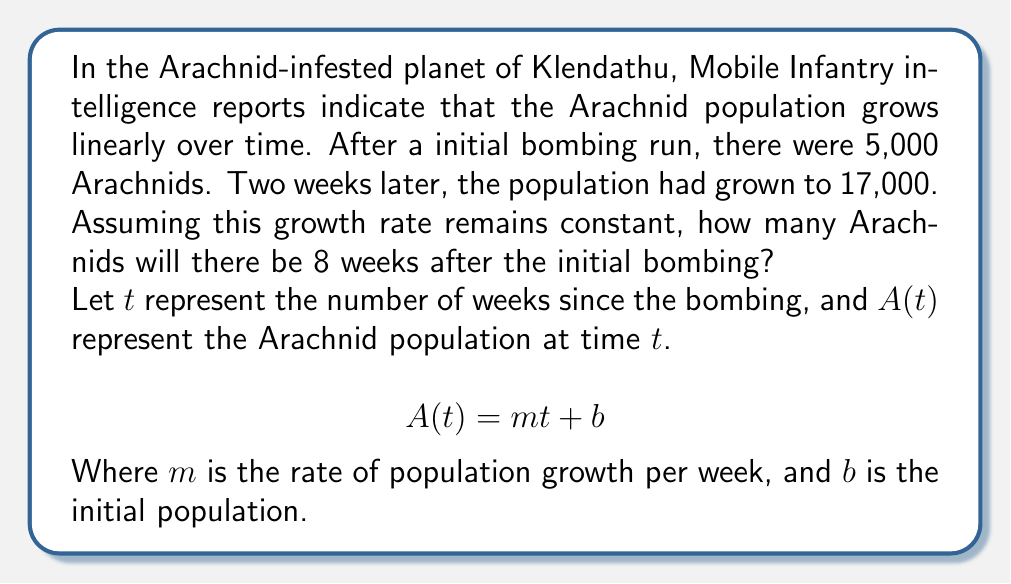Could you help me with this problem? Let's approach this problem step-by-step, like planning a strategic assault in an RTS game:

1) We know the initial population (b) is 5,000:
   $$A(0) = b = 5,000$$

2) We can set up an equation for the population after 2 weeks:
   $$A(2) = m(2) + 5,000 = 17,000$$

3) Now we can solve for the rate of growth (m):
   $$m(2) = 17,000 - 5,000$$
   $$m(2) = 12,000$$
   $$m = 6,000$$

4) So our linear equation for Arachnid population growth is:
   $$A(t) = 6,000t + 5,000$$

5) To find the population after 8 weeks, we substitute t = 8:
   $$A(8) = 6,000(8) + 5,000$$
   $$A(8) = 48,000 + 5,000$$
   $$A(8) = 53,000$$

Just as in Starship Troopers, the Arachnid threat grows rapidly if left unchecked!
Answer: 53,000 Arachnids 